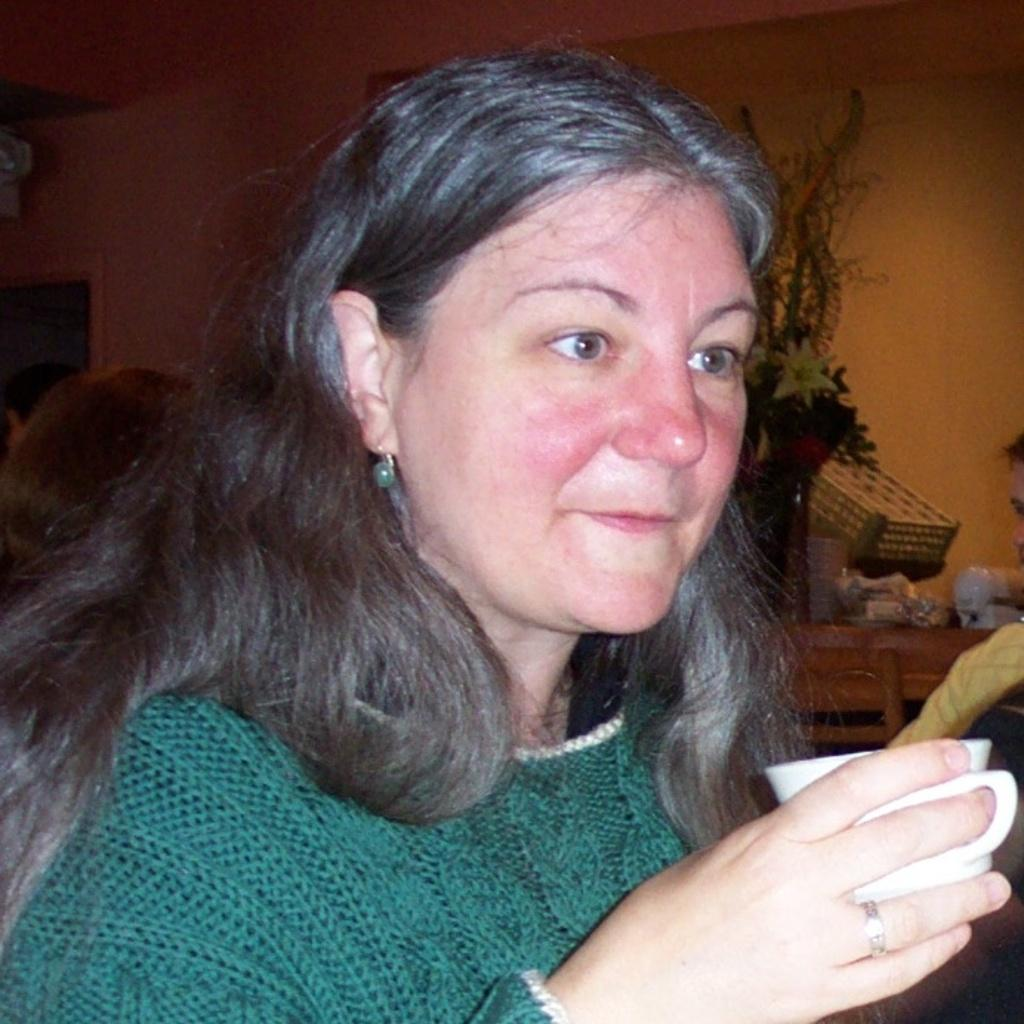Who is present in the image? There is a woman in the image. What is the woman holding in her hand? The woman is holding a cup in her hand. What can be seen behind the woman? There is a wall behind the woman. What is placed on the table in front of the wall? A bouquet is placed on the table. What type of rhythm does the woman's voice have in the image? There is no indication of the woman's voice or any rhythm in the image, as it only shows her holding a cup and standing in front of a wall with a bouquet on a table. 